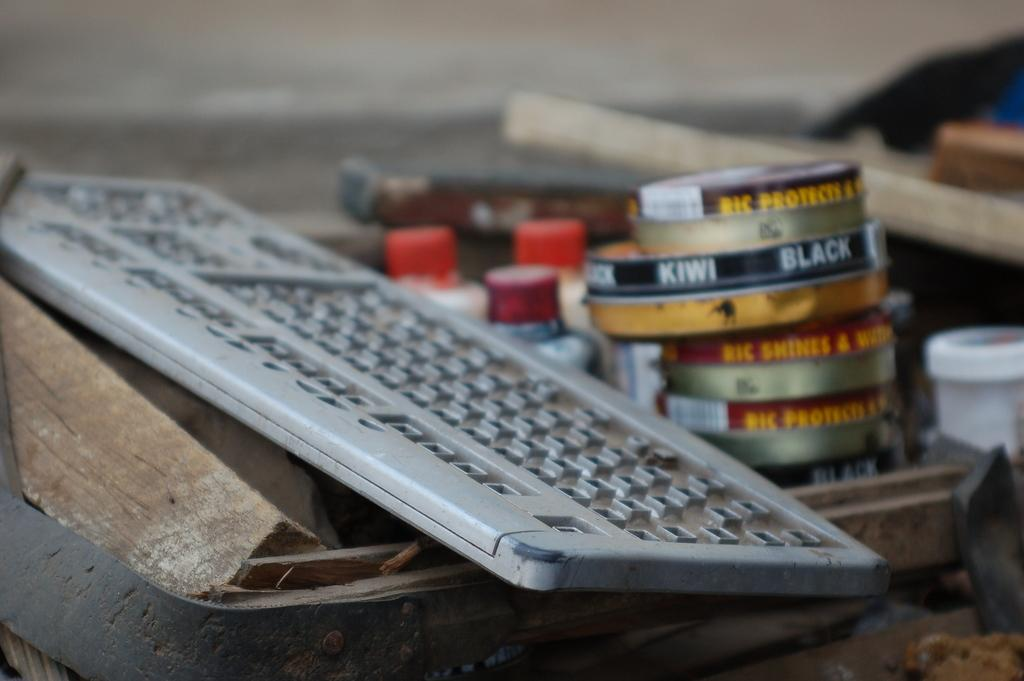<image>
Describe the image concisely. An old keyboard is stacked on a create next to Kiwi Black shoe polish. 